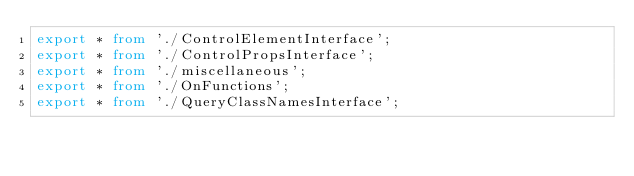Convert code to text. <code><loc_0><loc_0><loc_500><loc_500><_TypeScript_>export * from './ControlElementInterface';
export * from './ControlPropsInterface';
export * from './miscellaneous';
export * from './OnFunctions';
export * from './QueryClassNamesInterface';
</code> 